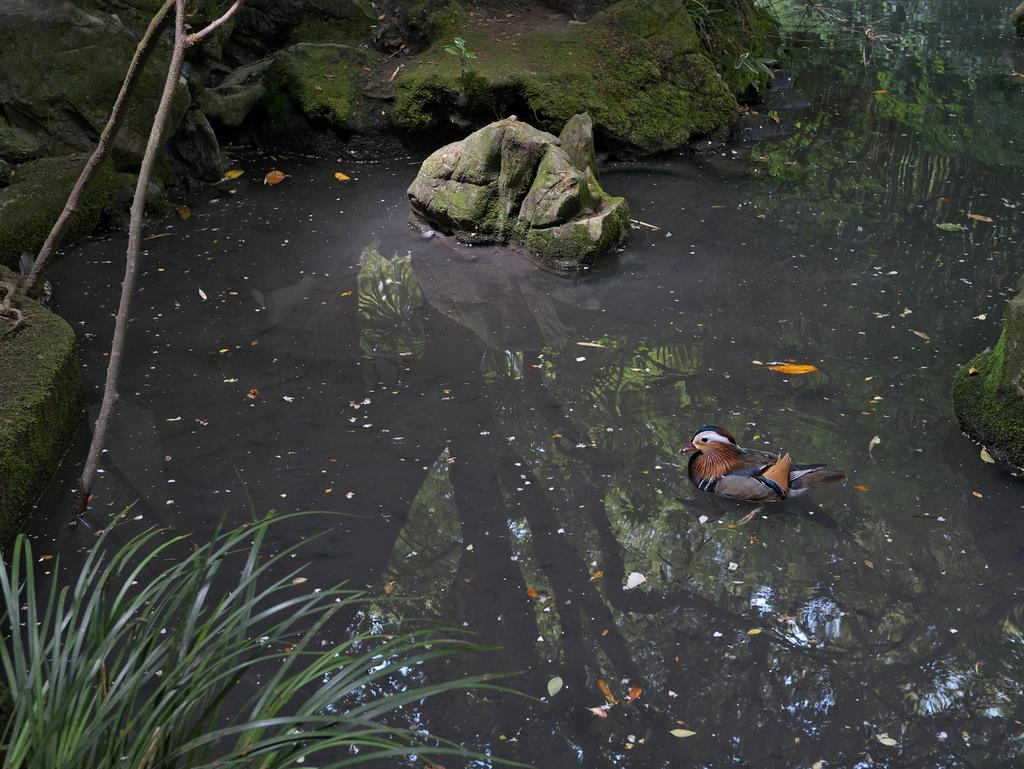What is in the water in the image? There is a bird in the water in the image. What else can be seen floating on the water? There are dry leaves on the water. What is a solid object visible in the image? There is a rock visible in the image. What can be seen in the top left corner of the image? There is a wooden object in the top left corner of the image. Can you touch the power lines in the image? There are no power lines present in the image. What type of farm can be seen in the background of the image? There is no farm visible in the image. 